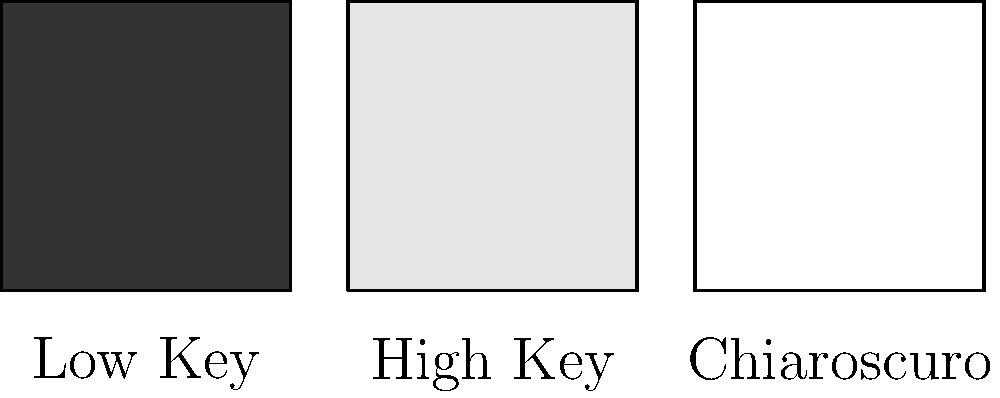Analyze the lighting techniques represented in the image above. Which of these would be most effective for creating a sense of mystery and tension in a film noir scene, and why? 1. Low Key Lighting: This technique uses predominantly dark tones and shadows with minimal fill light. It creates high contrast between the few highlighted areas and the abundant shadows.

2. High Key Lighting: This approach uses bright, even lighting with minimal shadows. It typically creates a cheerful or open atmosphere.

3. Chiaroscuro Lighting: This style employs a strong contrast between light and dark areas. It's characterized by pools of light surrounded by deep shadows.

For a film noir scene aiming to create mystery and tension:

1. Low Key Lighting would be most effective because:
   a) It creates deep shadows that can hide details or characters, enhancing the sense of the unknown.
   b) The high contrast between light and dark areas can create visual drama and unease.
   c) Limited illumination forces the audience to strain to see, mirroring the protagonist's struggle to uncover truth.

2. High Key Lighting would be least suitable as it typically creates an open, cheerful atmosphere contradictory to noir themes.

3. While Chiaroscuro can be effective for noir, Low Key is often preferred for its more extreme, shadowy effect.

Therefore, Low Key Lighting would be the most effective choice for creating mystery and tension in a film noir scene.
Answer: Low Key Lighting 